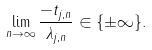<formula> <loc_0><loc_0><loc_500><loc_500>\lim _ { n \to \infty } \frac { - t _ { j , n } } { \lambda _ { j , n } } \in \{ \pm \infty \} .</formula> 